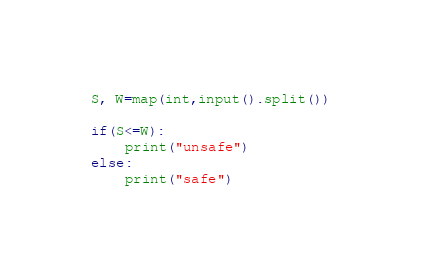<code> <loc_0><loc_0><loc_500><loc_500><_Python_>S, W=map(int,input().split())

if(S<=W):
    print("unsafe")
else:
    print("safe")
</code> 